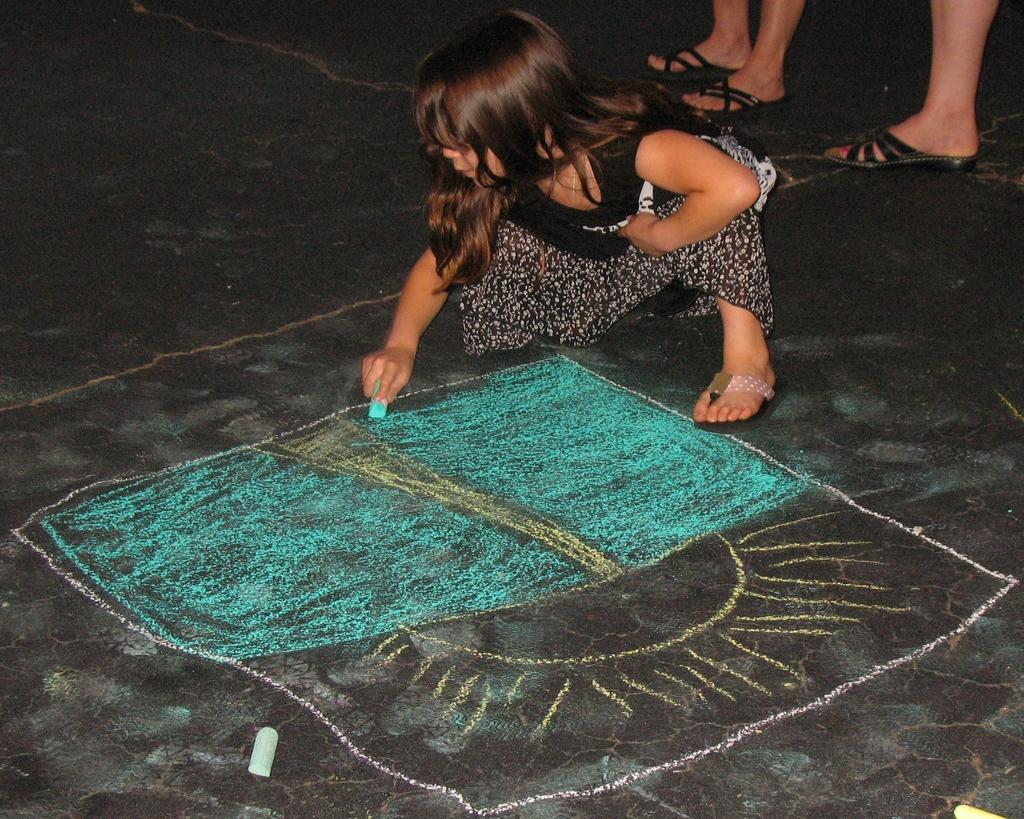Could you give a brief overview of what you see in this image? In this image we can see a girl drawing on the ground with a chalk. There is a chalk on the ground. There are few legs of the persons at the right side of the image. 